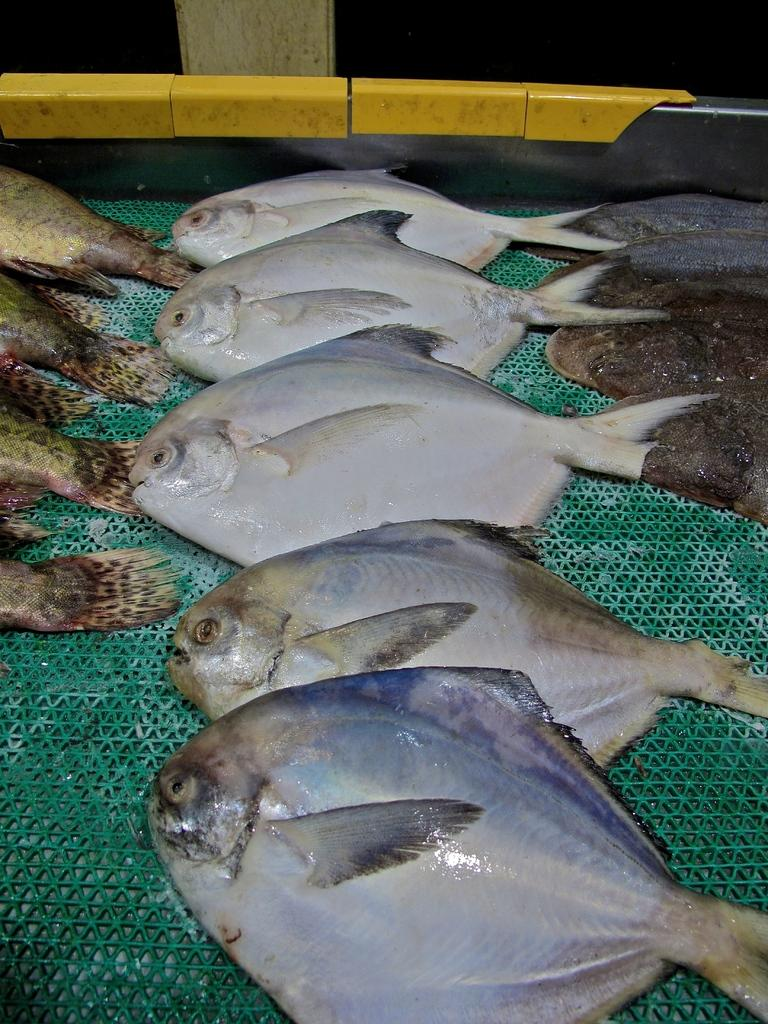What type of animals can be seen in the image? There are fishes in the image. What is the fishes resting on or in? The fishes are on a green object. What can be seen in the background of the image? There is a wooden pole in the background of the image. Can you tell me how many crackers are floating next to the fishes in the image? There are no crackers present in the image; it only features fishes on a green object and a wooden pole in the background. 